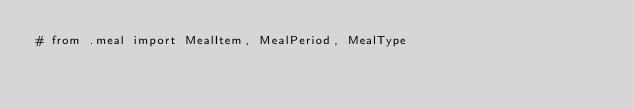Convert code to text. <code><loc_0><loc_0><loc_500><loc_500><_Python_># from .meal import MealItem, MealPeriod, MealType</code> 